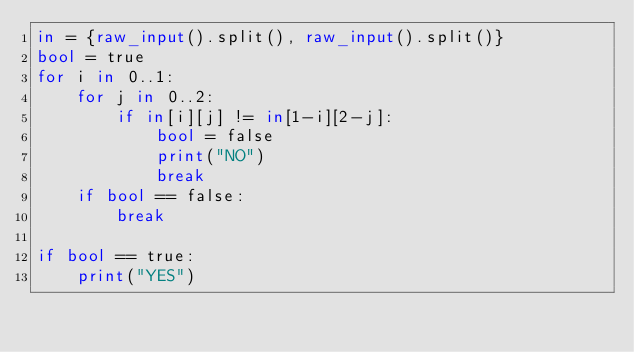Convert code to text. <code><loc_0><loc_0><loc_500><loc_500><_Python_>in = {raw_input().split(), raw_input().split()}
bool = true
for i in 0..1:
    for j in 0..2:
        if in[i][j] != in[1-i][2-j]:
            bool = false
            print("NO")
            break
    if bool == false:
        break
        
if bool == true:
    print("YES")</code> 